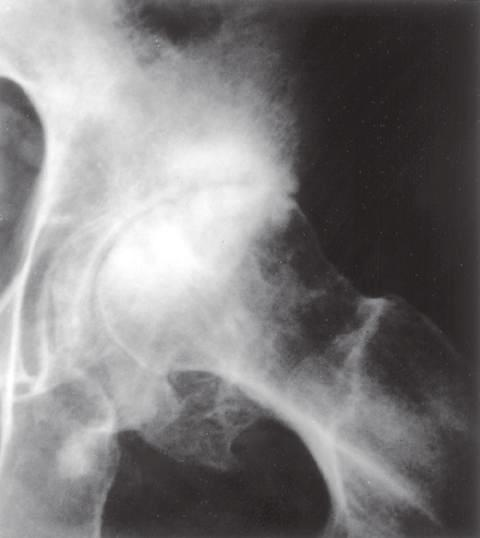what has scattered oval radiolucent cysts and peripheral osteophyte lipping arrows?
Answer the question using a single word or phrase. Subcondral sclerosis 